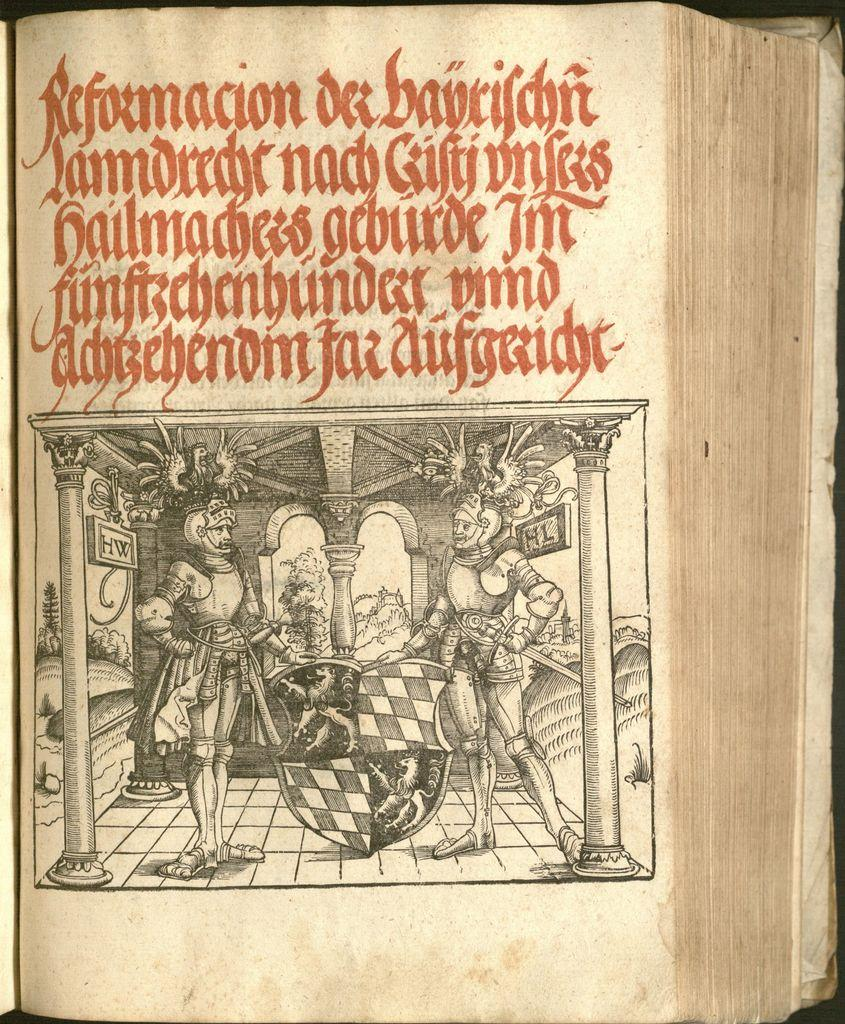<image>
Provide a brief description of the given image. A medieval looking book written in an unknown language, but the first word appears to be Reformacion. 